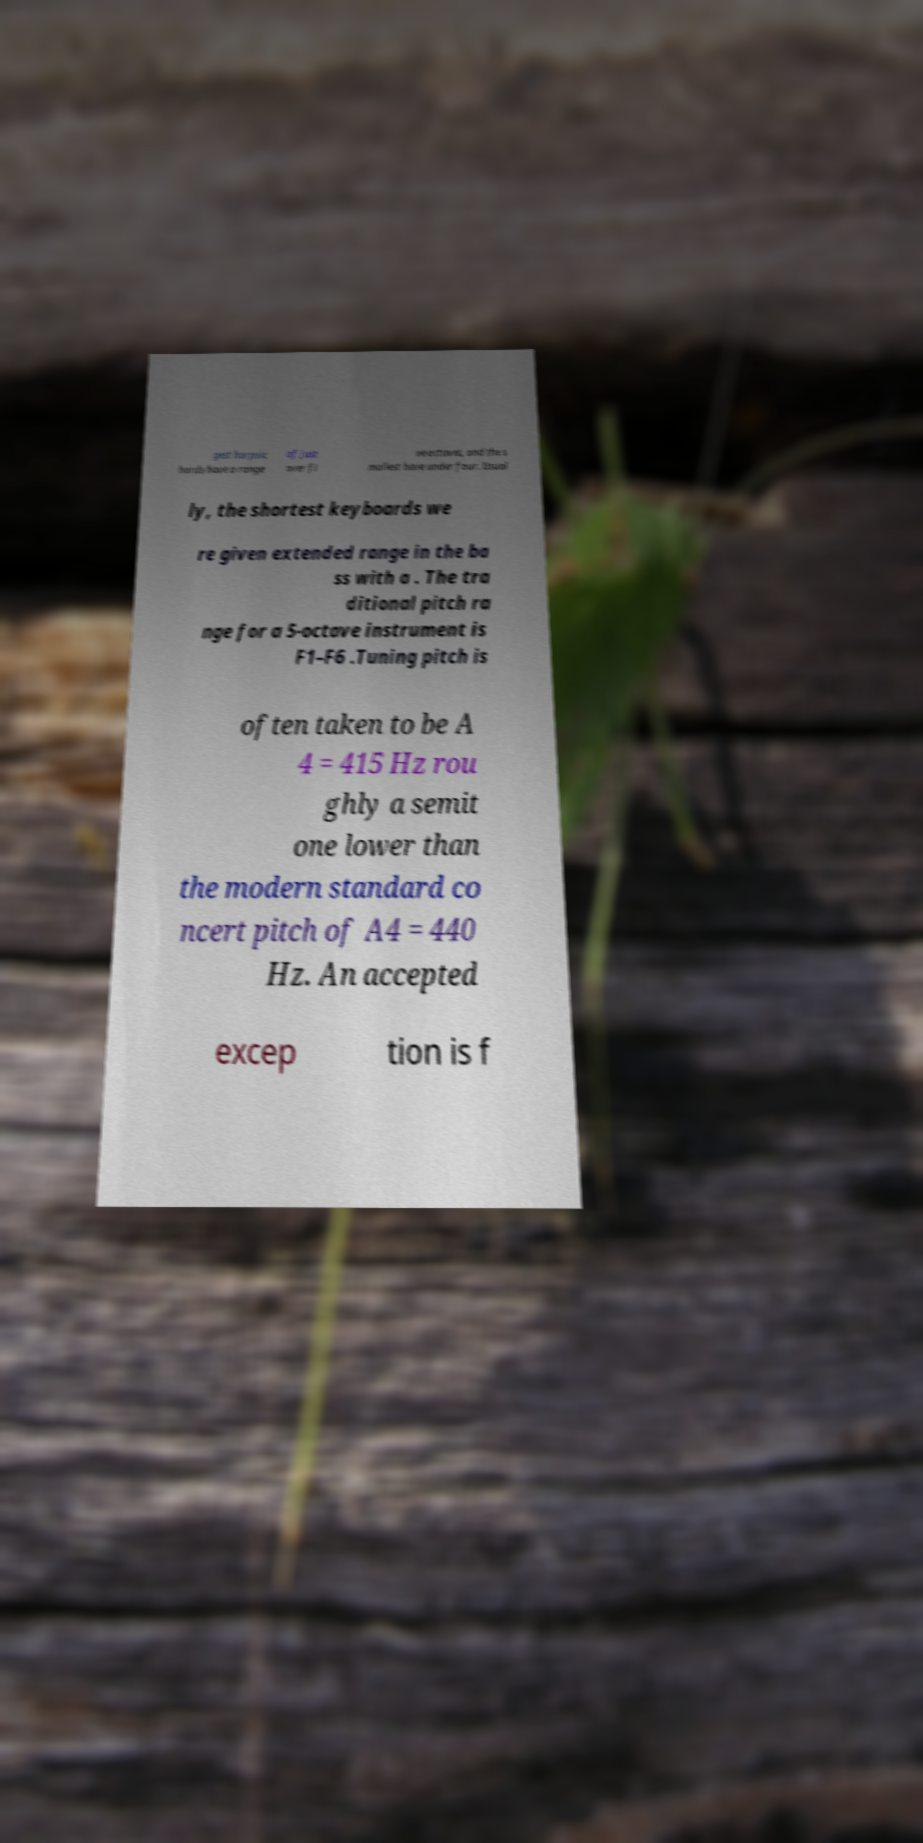I need the written content from this picture converted into text. Can you do that? gest harpsic hords have a range of just over fi ve octaves, and the s mallest have under four. Usual ly, the shortest keyboards we re given extended range in the ba ss with a . The tra ditional pitch ra nge for a 5-octave instrument is F1–F6 .Tuning pitch is often taken to be A 4 = 415 Hz rou ghly a semit one lower than the modern standard co ncert pitch of A4 = 440 Hz. An accepted excep tion is f 